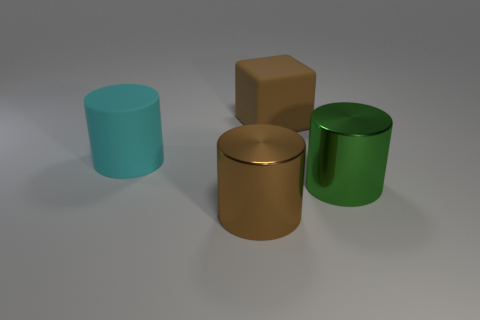How big is the green shiny thing?
Make the answer very short. Large. What number of objects are either cyan blocks or big metallic cylinders?
Your response must be concise. 2. What color is the other cylinder that is the same material as the big green cylinder?
Offer a very short reply. Brown. Is the shape of the large brown thing behind the cyan object the same as  the green object?
Give a very brief answer. No. What number of things are large cylinders that are on the right side of the big brown cylinder or big shiny things right of the brown cylinder?
Your answer should be compact. 1. There is a large matte object that is the same shape as the brown shiny object; what color is it?
Your answer should be very brief. Cyan. Is there any other thing that has the same shape as the big cyan thing?
Your response must be concise. Yes. Does the big cyan matte thing have the same shape as the brown object that is on the left side of the big block?
Offer a very short reply. Yes. What is the material of the big green thing?
Provide a succinct answer. Metal. The green shiny thing that is the same shape as the large cyan matte thing is what size?
Offer a terse response. Large. 